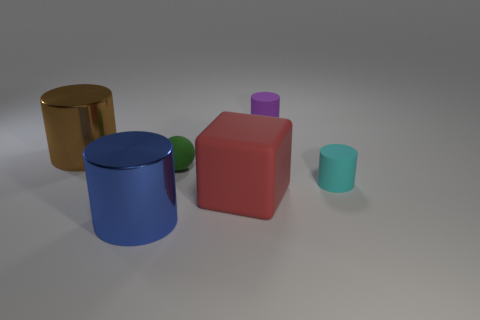Subtract all brown cylinders. How many cylinders are left? 3 Subtract all big blue cylinders. How many cylinders are left? 3 Add 1 brown cylinders. How many objects exist? 7 Subtract all gray cylinders. Subtract all purple blocks. How many cylinders are left? 4 Subtract all blocks. How many objects are left? 5 Add 2 red metal blocks. How many red metal blocks exist? 2 Subtract 0 gray spheres. How many objects are left? 6 Subtract all red cylinders. Subtract all large shiny cylinders. How many objects are left? 4 Add 1 green rubber things. How many green rubber things are left? 2 